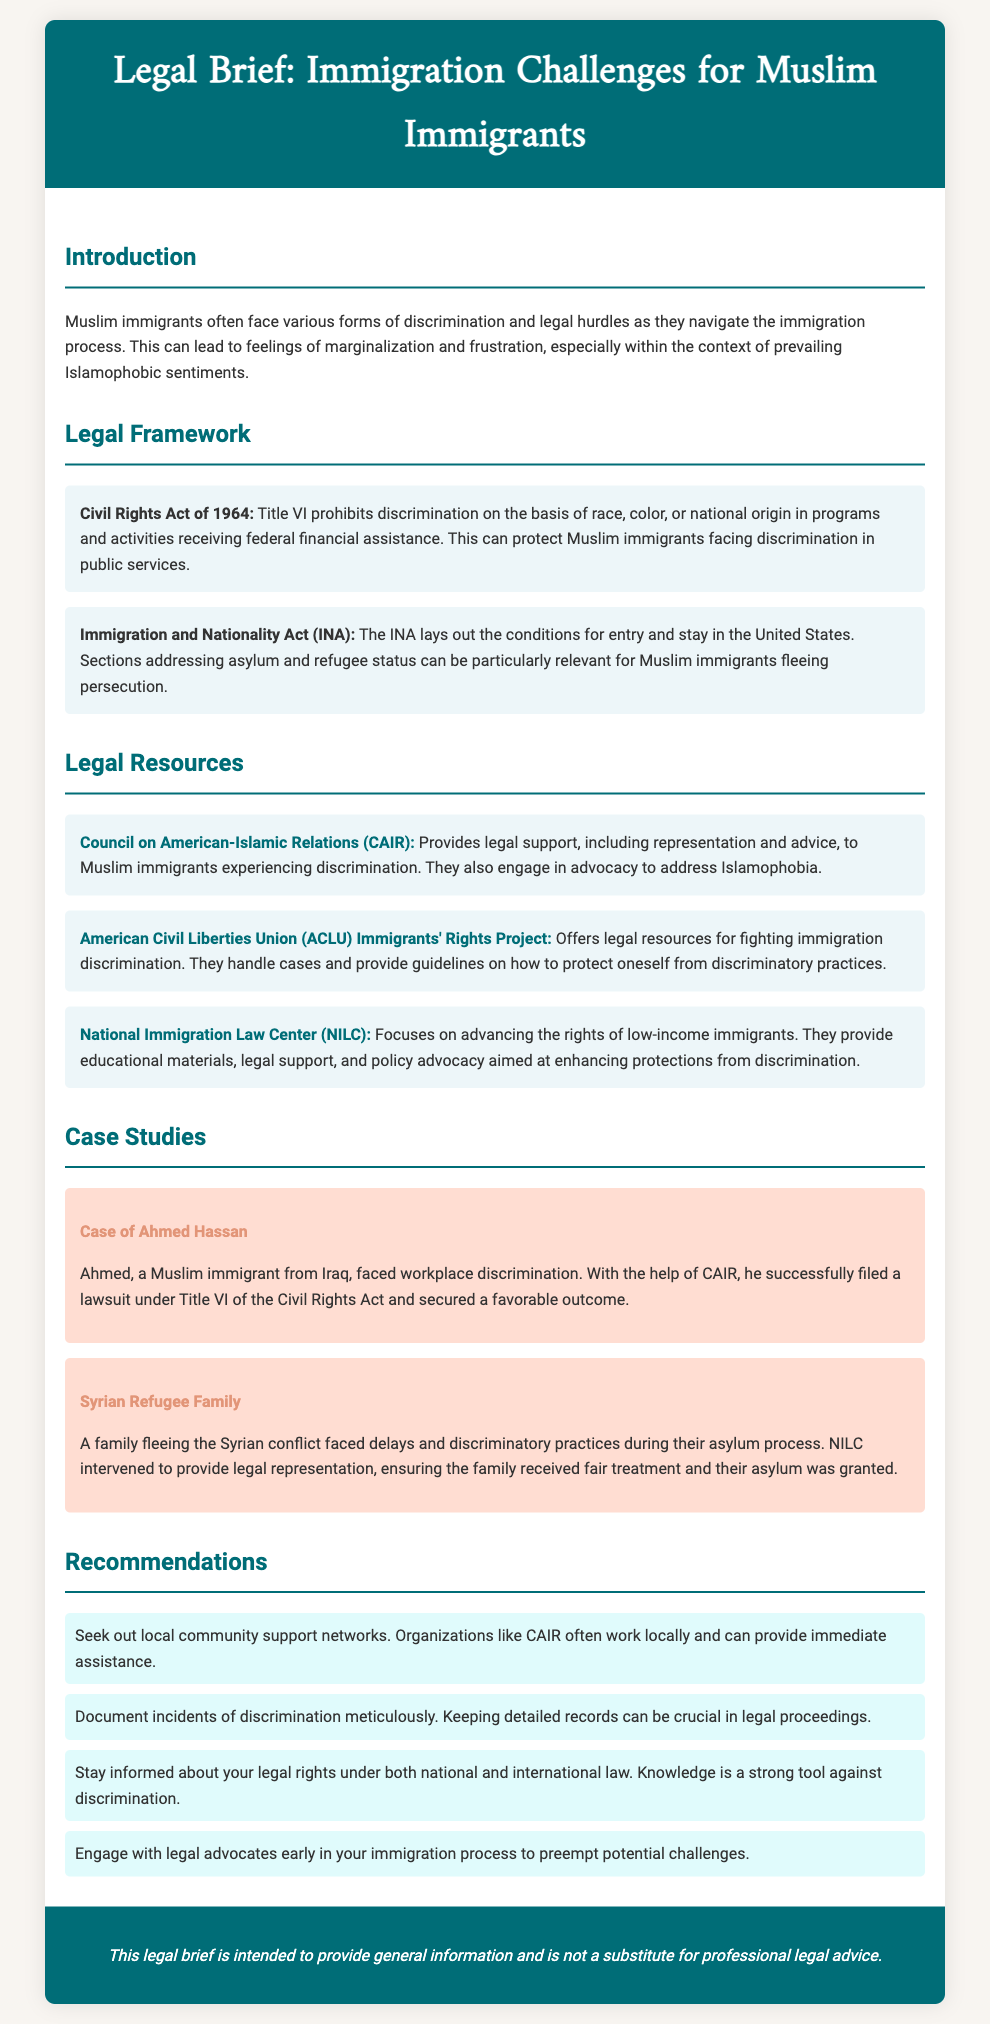What legal act prohibits discrimination based on national origin? The document states that Title VI of the Civil Rights Act of 1964 prohibits discrimination on the basis of race, color, or national origin.
Answer: Civil Rights Act of 1964 Which organization provides legal support to Muslim immigrants? The document lists the Council on American-Islamic Relations (CAIR) as an organization providing legal support to Muslim immigrants experiencing discrimination.
Answer: CAIR Who was helped by CAIR in a workplace discrimination case? The document mentions a case study involving Ahmed Hassan, who was assisted by CAIR in filing a lawsuit under Title VI of the Civil Rights Act.
Answer: Ahmed Hassan What is a recommended action to take if facing discrimination? The document recommends documenting incidents of discrimination meticulously as a crucial step in legal proceedings.
Answer: Document incidents Which foundation focuses on the rights of low-income immigrants? The National Immigration Law Center (NILC) is specified in the document as focusing on the rights of low-income immigrants.
Answer: NILC What type of brief is this document classified as? The document is classified as a legal brief specifically addressing immigration challenges for Muslim immigrants.
Answer: Legal brief How many case studies are provided in the document? The document includes two case studies related to discrimination faced by Muslim immigrants.
Answer: Two case studies What legal framework lays out conditions for entry and stay in the U.S.? The Immigration and Nationality Act (INA) outlines the conditions for entry and stay in the United States.
Answer: Immigration and Nationality Act (INA) 